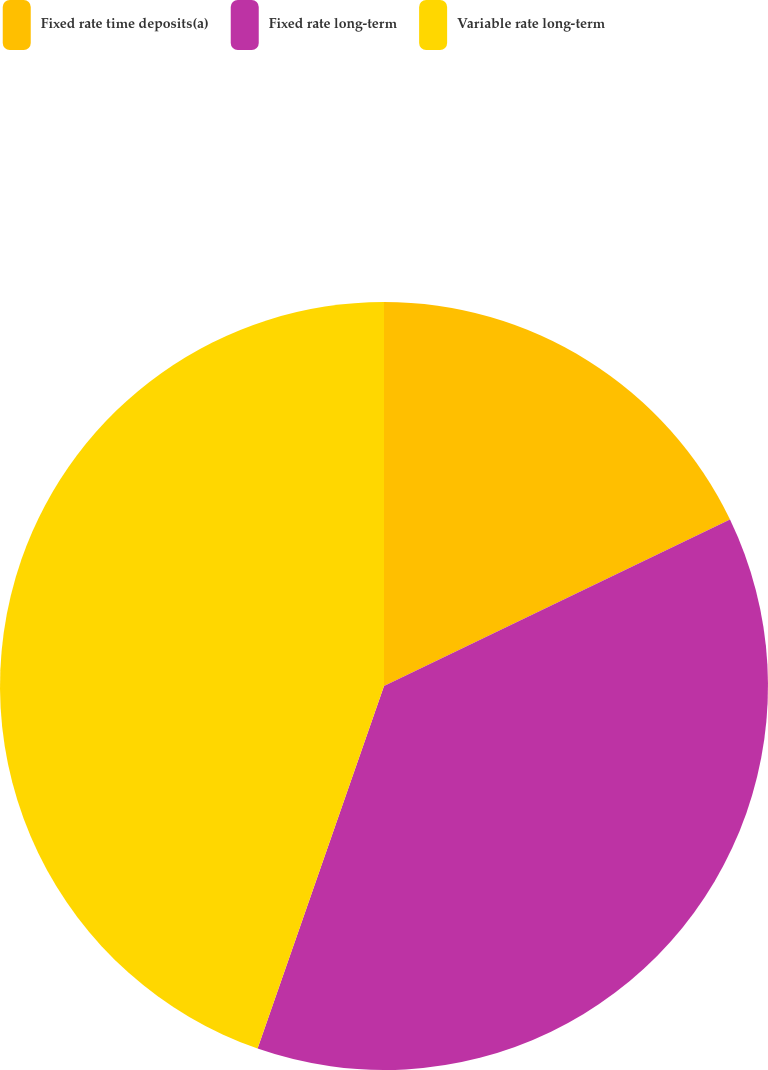Convert chart to OTSL. <chart><loc_0><loc_0><loc_500><loc_500><pie_chart><fcel>Fixed rate time deposits(a)<fcel>Fixed rate long-term<fcel>Variable rate long-term<nl><fcel>17.86%<fcel>37.48%<fcel>44.66%<nl></chart> 